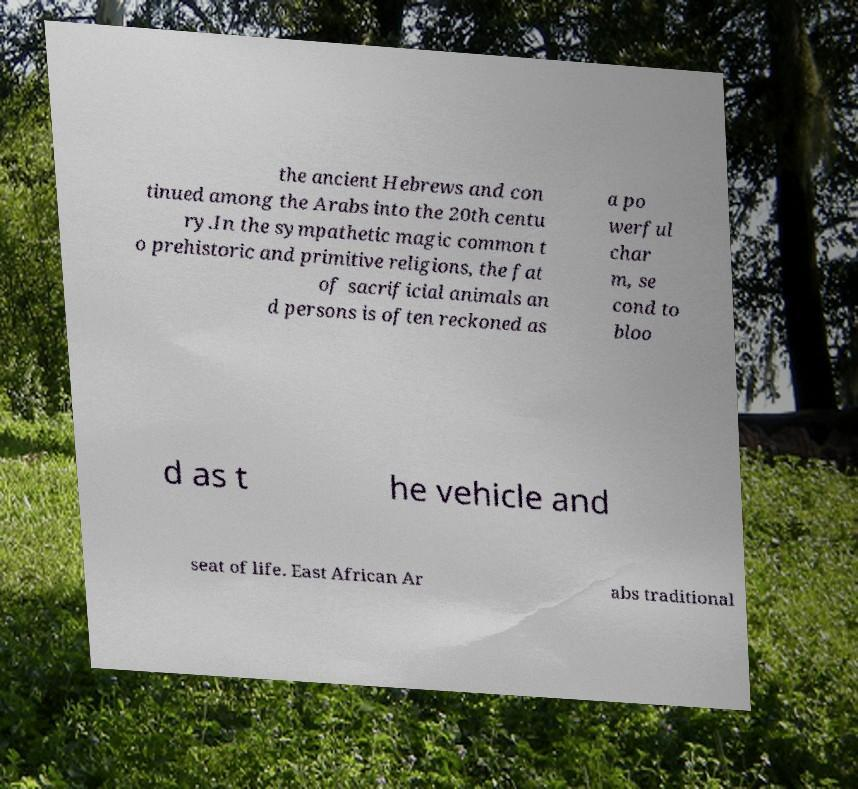For documentation purposes, I need the text within this image transcribed. Could you provide that? the ancient Hebrews and con tinued among the Arabs into the 20th centu ry.In the sympathetic magic common t o prehistoric and primitive religions, the fat of sacrificial animals an d persons is often reckoned as a po werful char m, se cond to bloo d as t he vehicle and seat of life. East African Ar abs traditional 